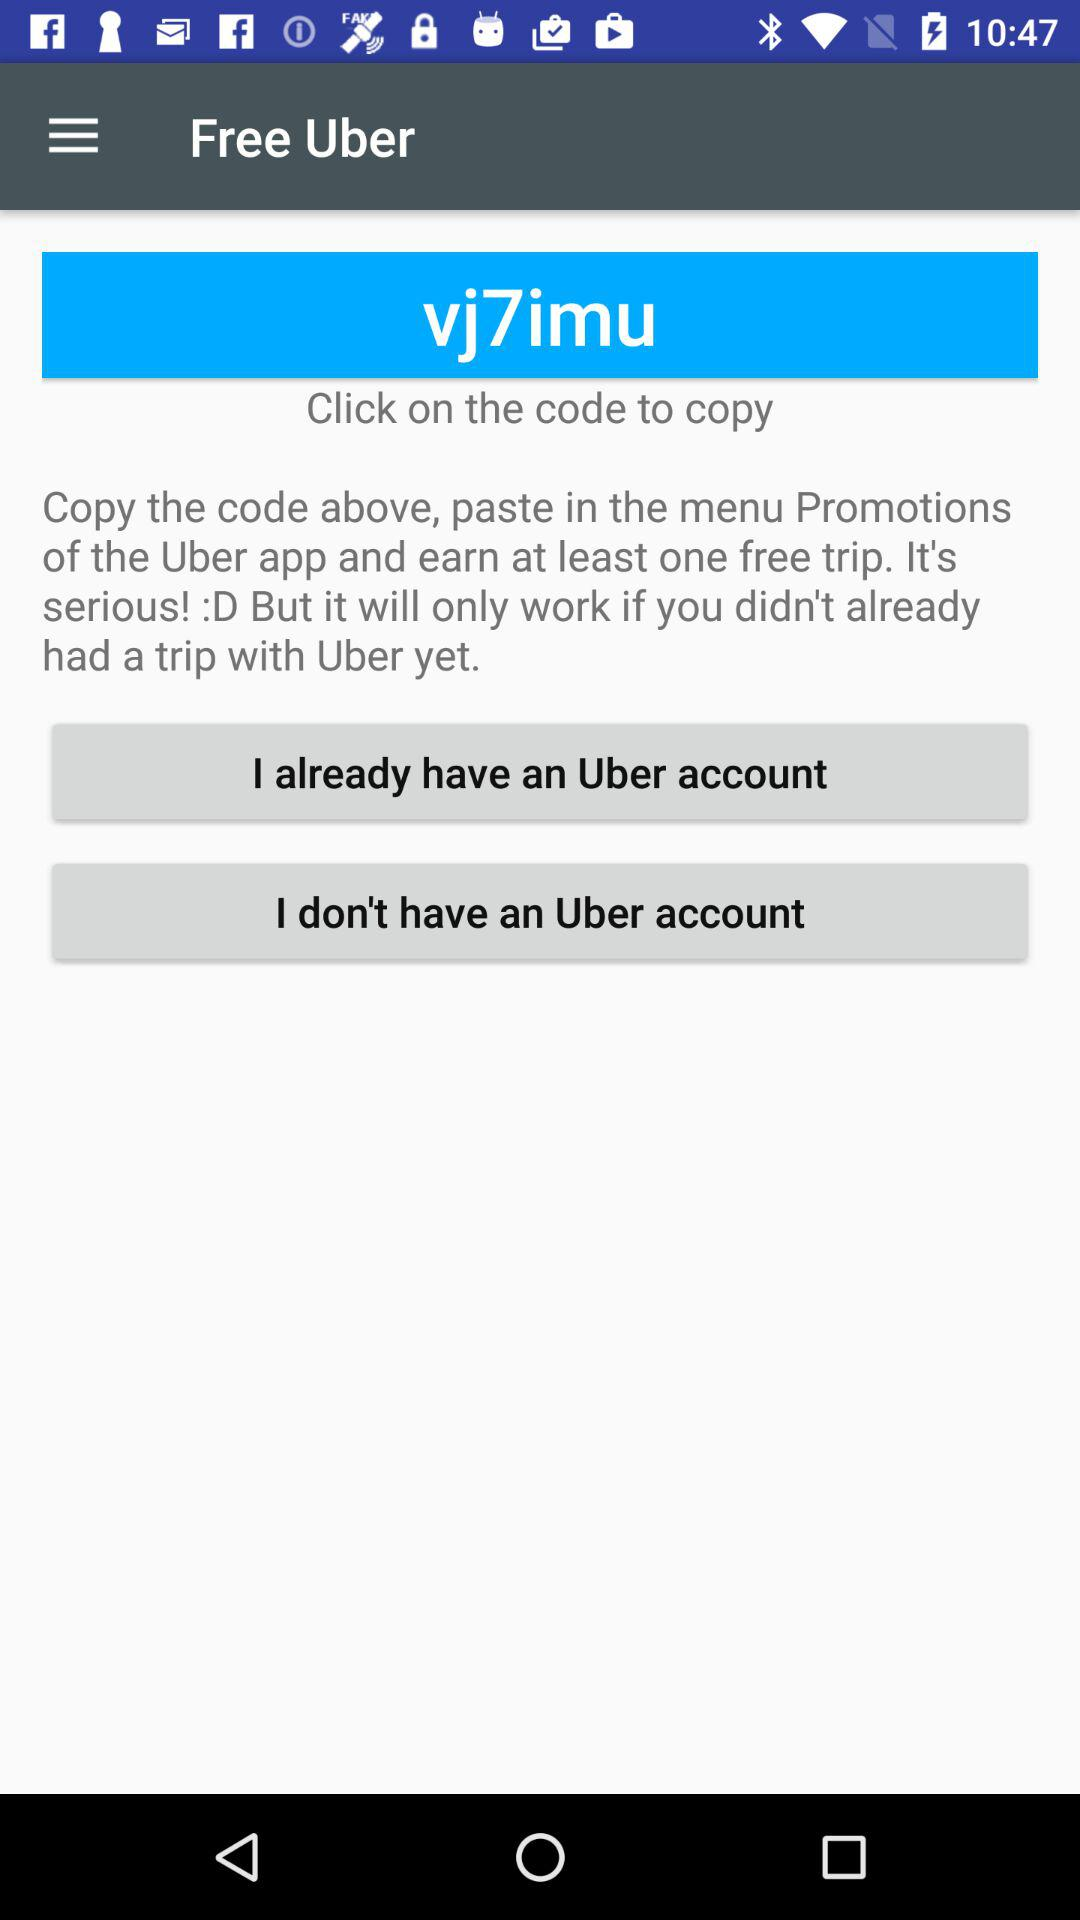What is the app's name? The app's name is "Uber". 